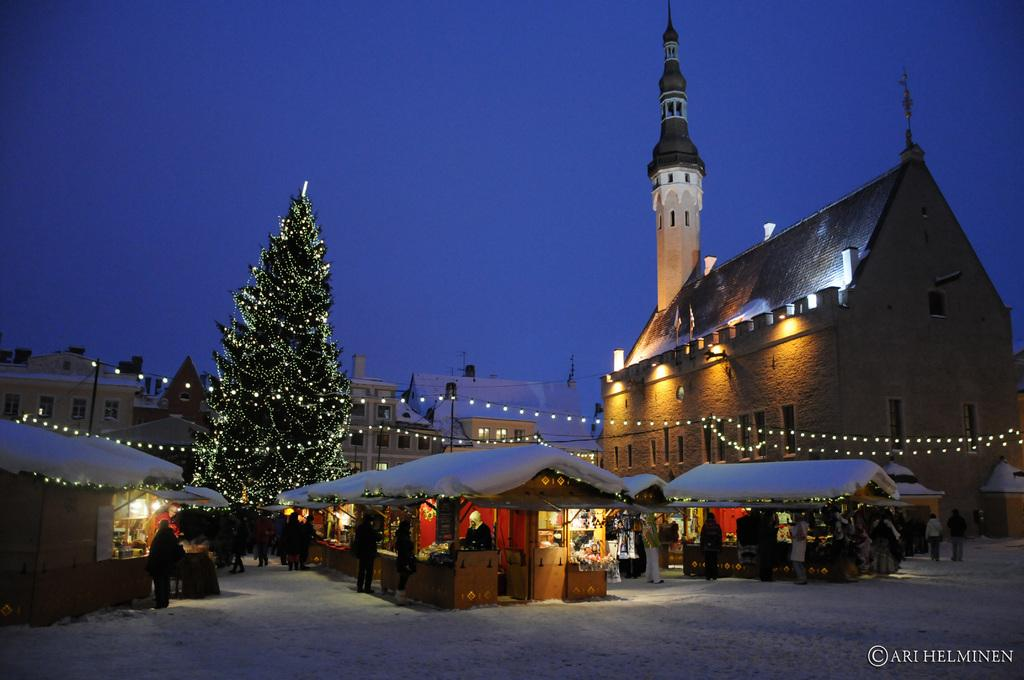How many persons can be seen in the image? There are persons in the image, but the exact number is not specified. What type of structures are present in the image? There are huts and buildings in the image. What is the main feature in the middle of the image? There is a Christmas tree in the middle of the image. What type of lighting is present in the image? Rope lights are present in the image. What can be seen in the background of the image? There is a sky visible in the background of the image. How many bikes are parked near the huts in the image? There is no mention of bikes in the image, so we cannot determine how many there might be. Can you describe the squirrel sitting on the Christmas tree in the image? There is no squirrel present in the image; it only features a Christmas tree and rope lights. 